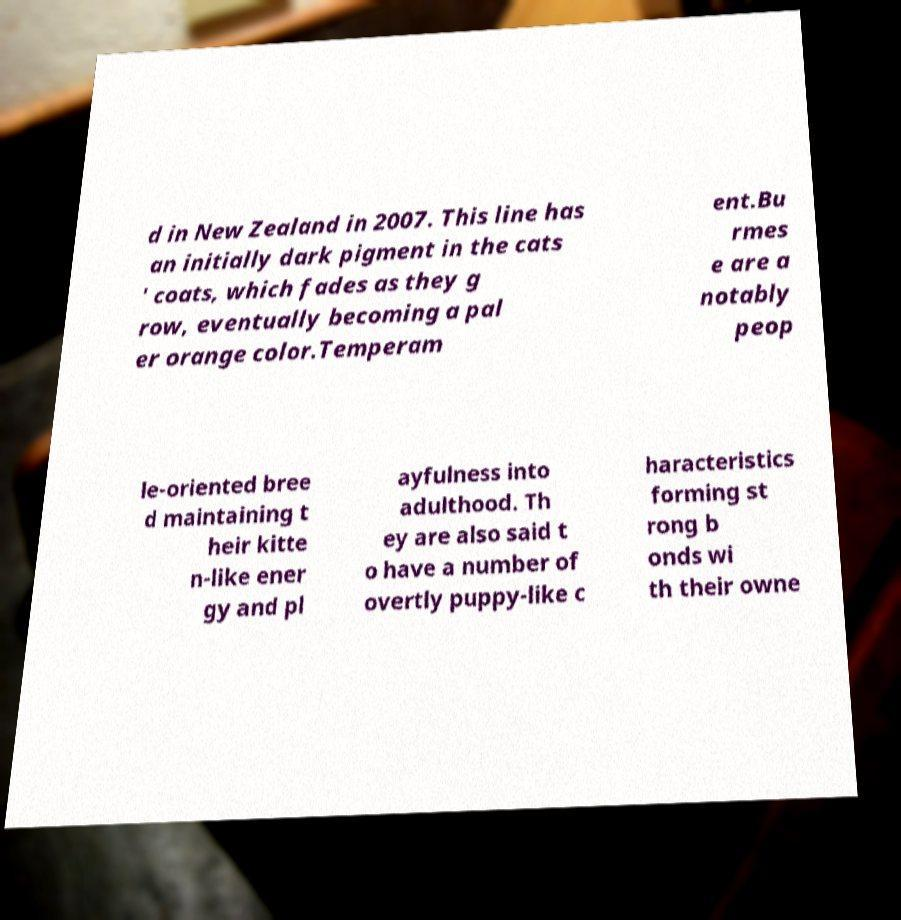Can you read and provide the text displayed in the image?This photo seems to have some interesting text. Can you extract and type it out for me? d in New Zealand in 2007. This line has an initially dark pigment in the cats ' coats, which fades as they g row, eventually becoming a pal er orange color.Temperam ent.Bu rmes e are a notably peop le-oriented bree d maintaining t heir kitte n-like ener gy and pl ayfulness into adulthood. Th ey are also said t o have a number of overtly puppy-like c haracteristics forming st rong b onds wi th their owne 